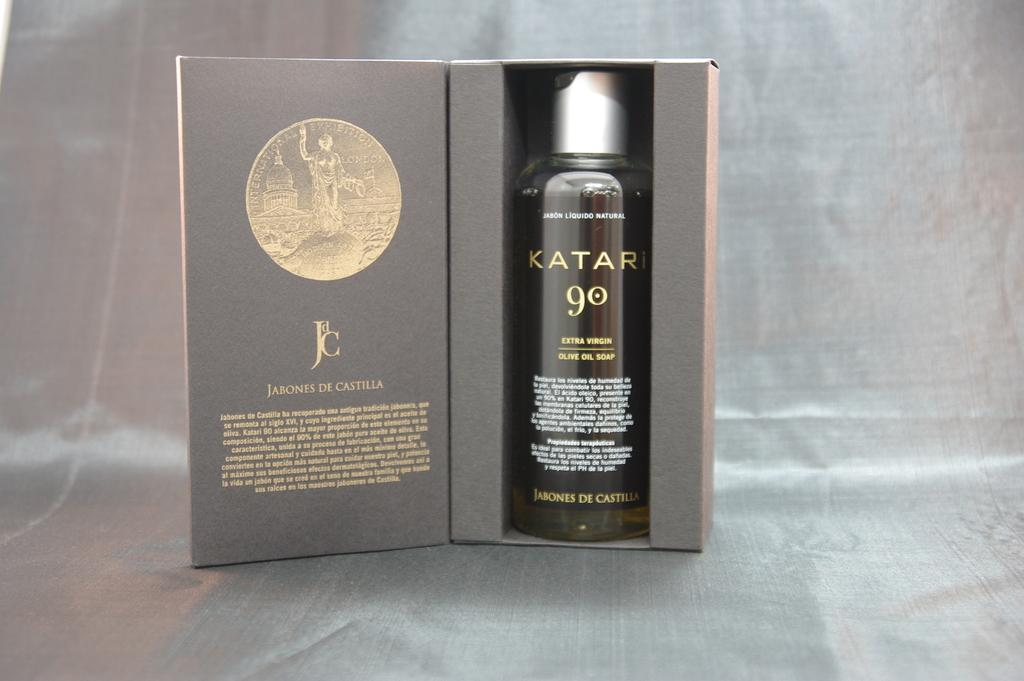<image>
Describe the image concisely. A bottle of Katari olive oil soap sits in a box. 